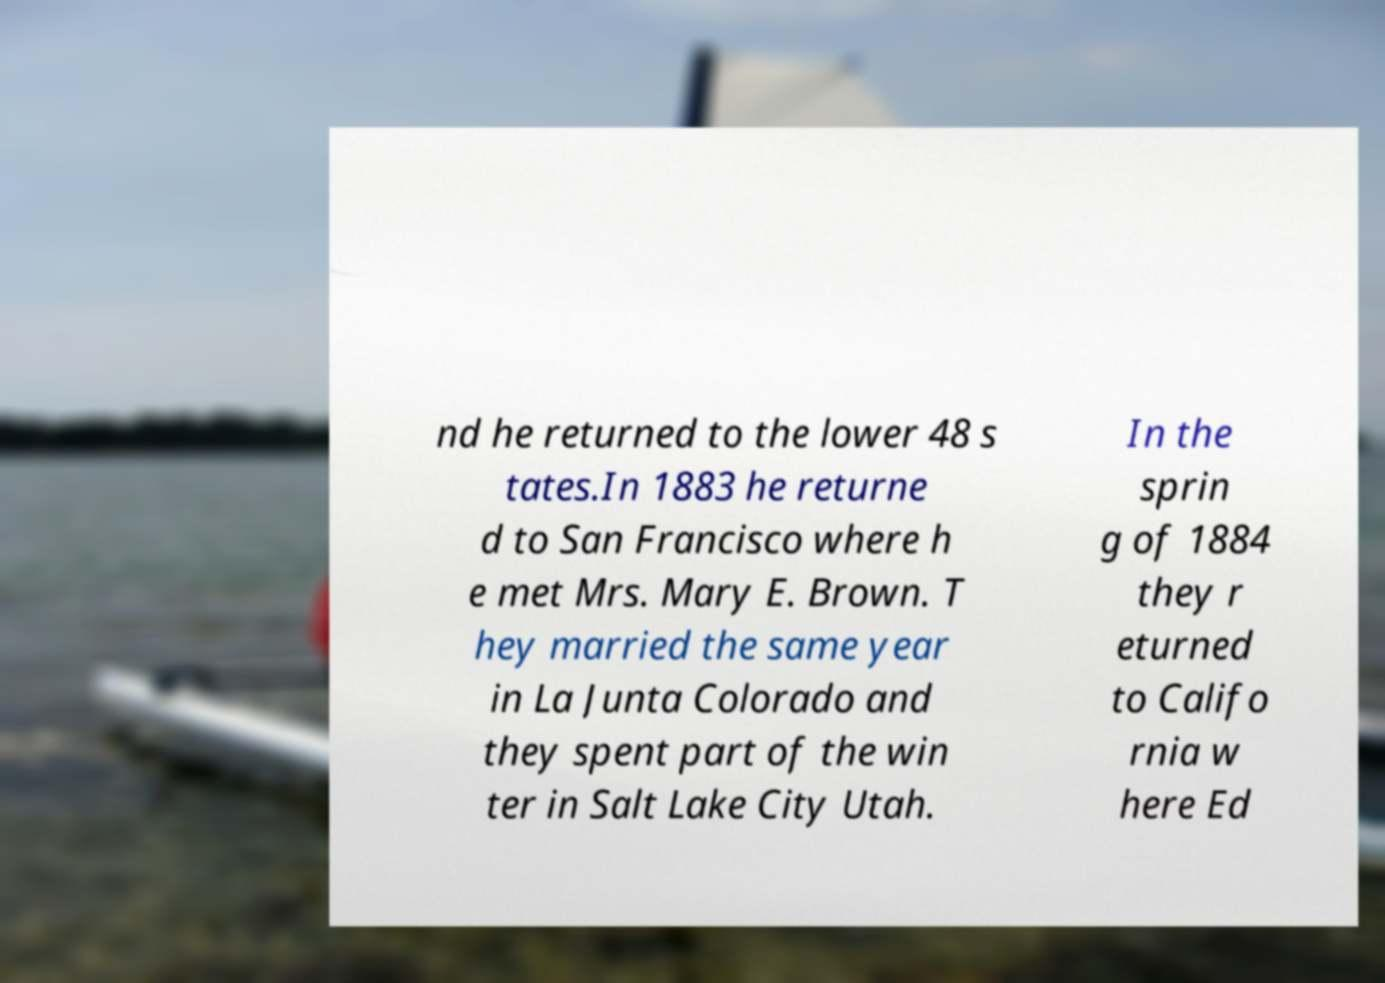Could you extract and type out the text from this image? nd he returned to the lower 48 s tates.In 1883 he returne d to San Francisco where h e met Mrs. Mary E. Brown. T hey married the same year in La Junta Colorado and they spent part of the win ter in Salt Lake City Utah. In the sprin g of 1884 they r eturned to Califo rnia w here Ed 